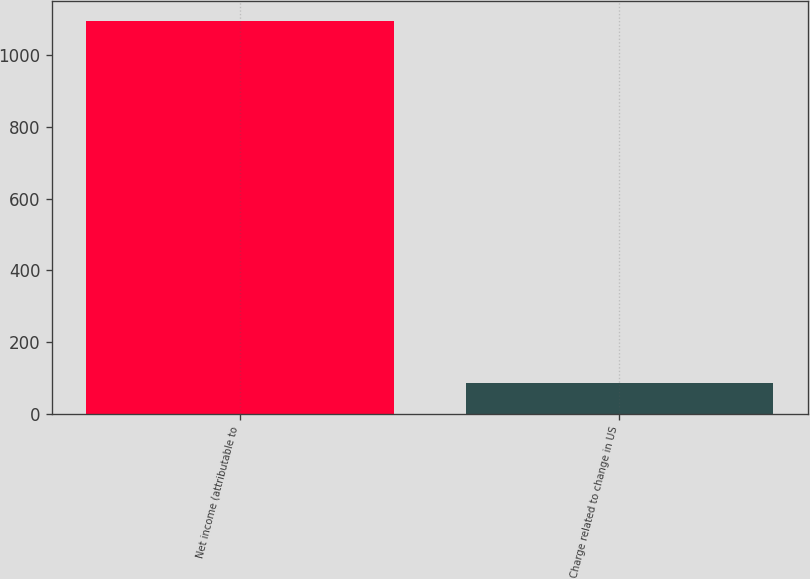Convert chart to OTSL. <chart><loc_0><loc_0><loc_500><loc_500><bar_chart><fcel>Net income (attributable to<fcel>Charge related to change in US<nl><fcel>1095<fcel>85<nl></chart> 